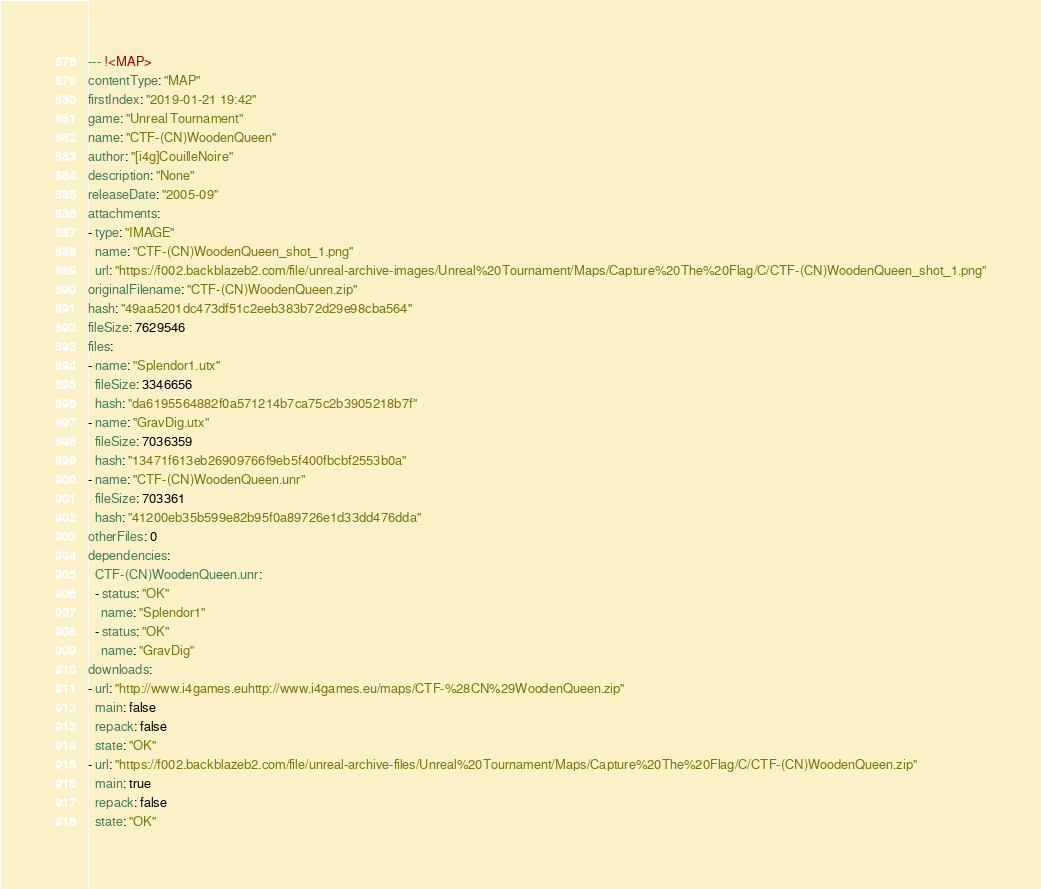Convert code to text. <code><loc_0><loc_0><loc_500><loc_500><_YAML_>--- !<MAP>
contentType: "MAP"
firstIndex: "2019-01-21 19:42"
game: "Unreal Tournament"
name: "CTF-(CN)WoodenQueen"
author: "[i4g]CouilleNoire"
description: "None"
releaseDate: "2005-09"
attachments:
- type: "IMAGE"
  name: "CTF-(CN)WoodenQueen_shot_1.png"
  url: "https://f002.backblazeb2.com/file/unreal-archive-images/Unreal%20Tournament/Maps/Capture%20The%20Flag/C/CTF-(CN)WoodenQueen_shot_1.png"
originalFilename: "CTF-(CN)WoodenQueen.zip"
hash: "49aa5201dc473df51c2eeb383b72d29e98cba564"
fileSize: 7629546
files:
- name: "Splendor1.utx"
  fileSize: 3346656
  hash: "da6195564882f0a571214b7ca75c2b3905218b7f"
- name: "GravDig.utx"
  fileSize: 7036359
  hash: "13471f613eb26909766f9eb5f400fbcbf2553b0a"
- name: "CTF-(CN)WoodenQueen.unr"
  fileSize: 703361
  hash: "41200eb35b599e82b95f0a89726e1d33dd476dda"
otherFiles: 0
dependencies:
  CTF-(CN)WoodenQueen.unr:
  - status: "OK"
    name: "Splendor1"
  - status: "OK"
    name: "GravDig"
downloads:
- url: "http://www.i4games.euhttp://www.i4games.eu/maps/CTF-%28CN%29WoodenQueen.zip"
  main: false
  repack: false
  state: "OK"
- url: "https://f002.backblazeb2.com/file/unreal-archive-files/Unreal%20Tournament/Maps/Capture%20The%20Flag/C/CTF-(CN)WoodenQueen.zip"
  main: true
  repack: false
  state: "OK"</code> 